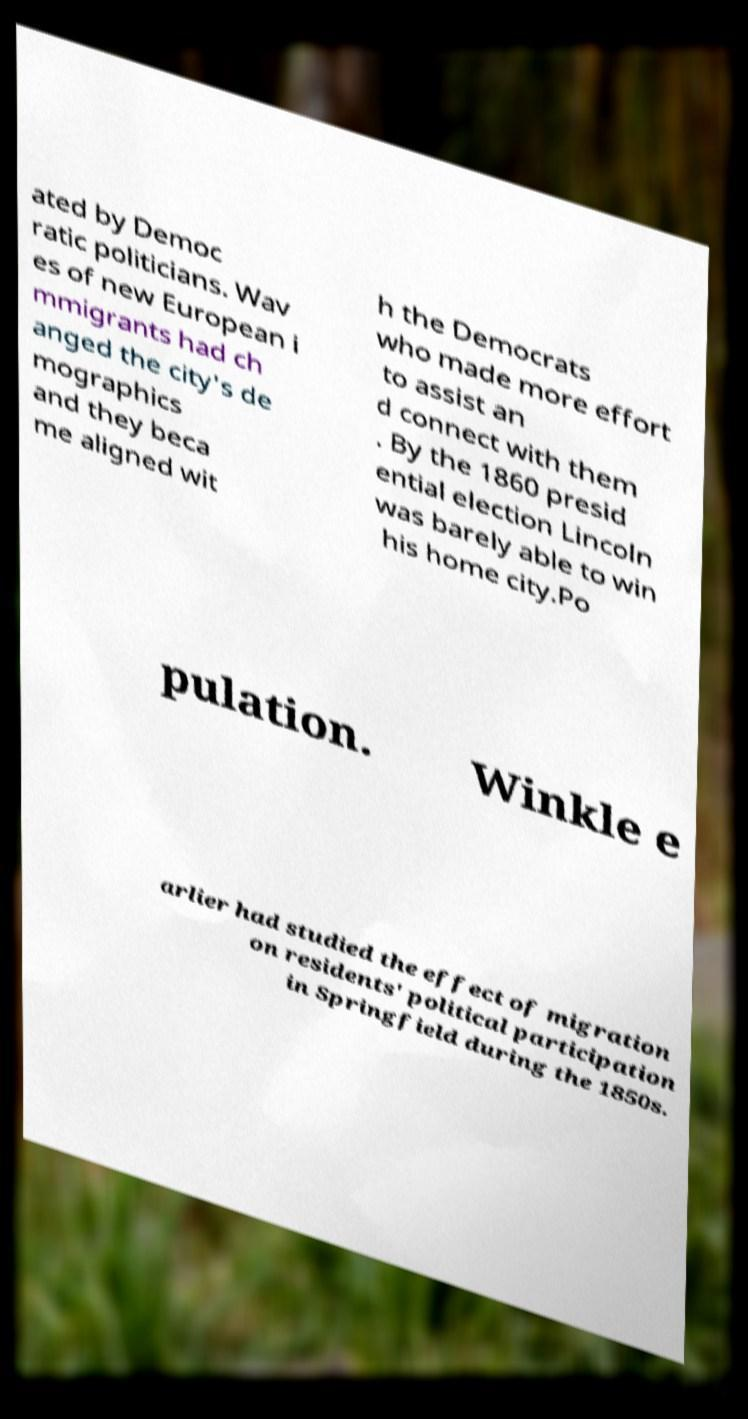Could you extract and type out the text from this image? ated by Democ ratic politicians. Wav es of new European i mmigrants had ch anged the city's de mographics and they beca me aligned wit h the Democrats who made more effort to assist an d connect with them . By the 1860 presid ential election Lincoln was barely able to win his home city.Po pulation. Winkle e arlier had studied the effect of migration on residents' political participation in Springfield during the 1850s. 